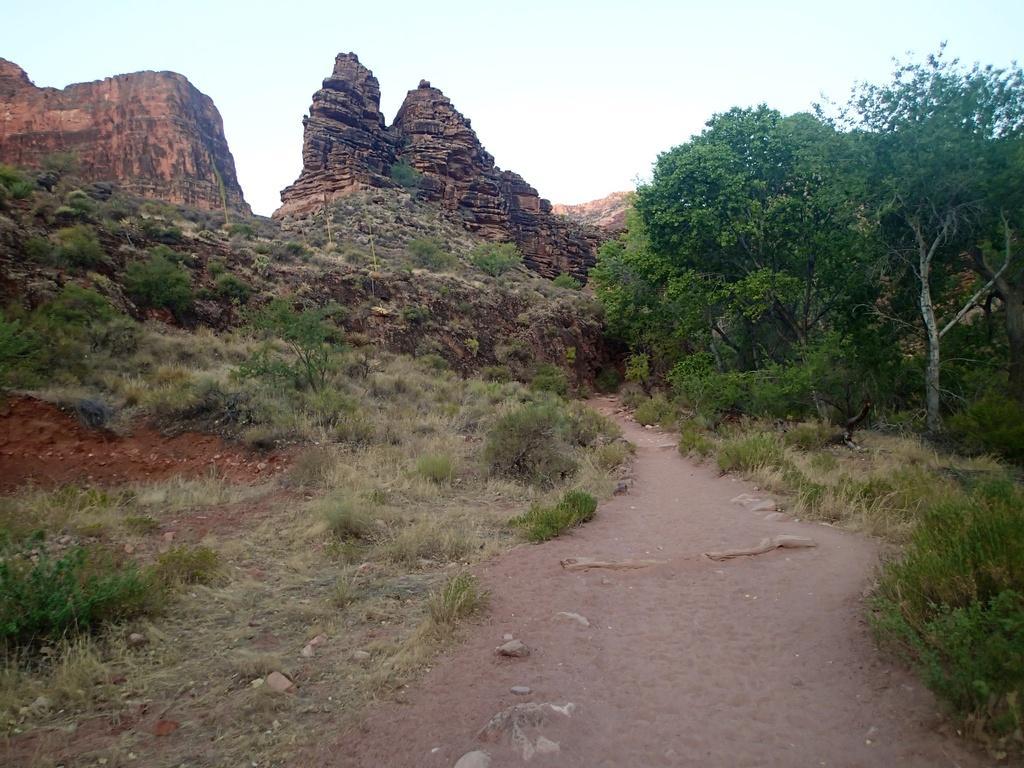Describe this image in one or two sentences. In this picture we can see path, grass, plants, trees and rocks. In the background of the image we can see the sky. 